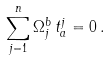Convert formula to latex. <formula><loc_0><loc_0><loc_500><loc_500>\sum _ { j = 1 } ^ { n } \Omega _ { j } ^ { b } \, t _ { a } ^ { j } = 0 \, .</formula> 